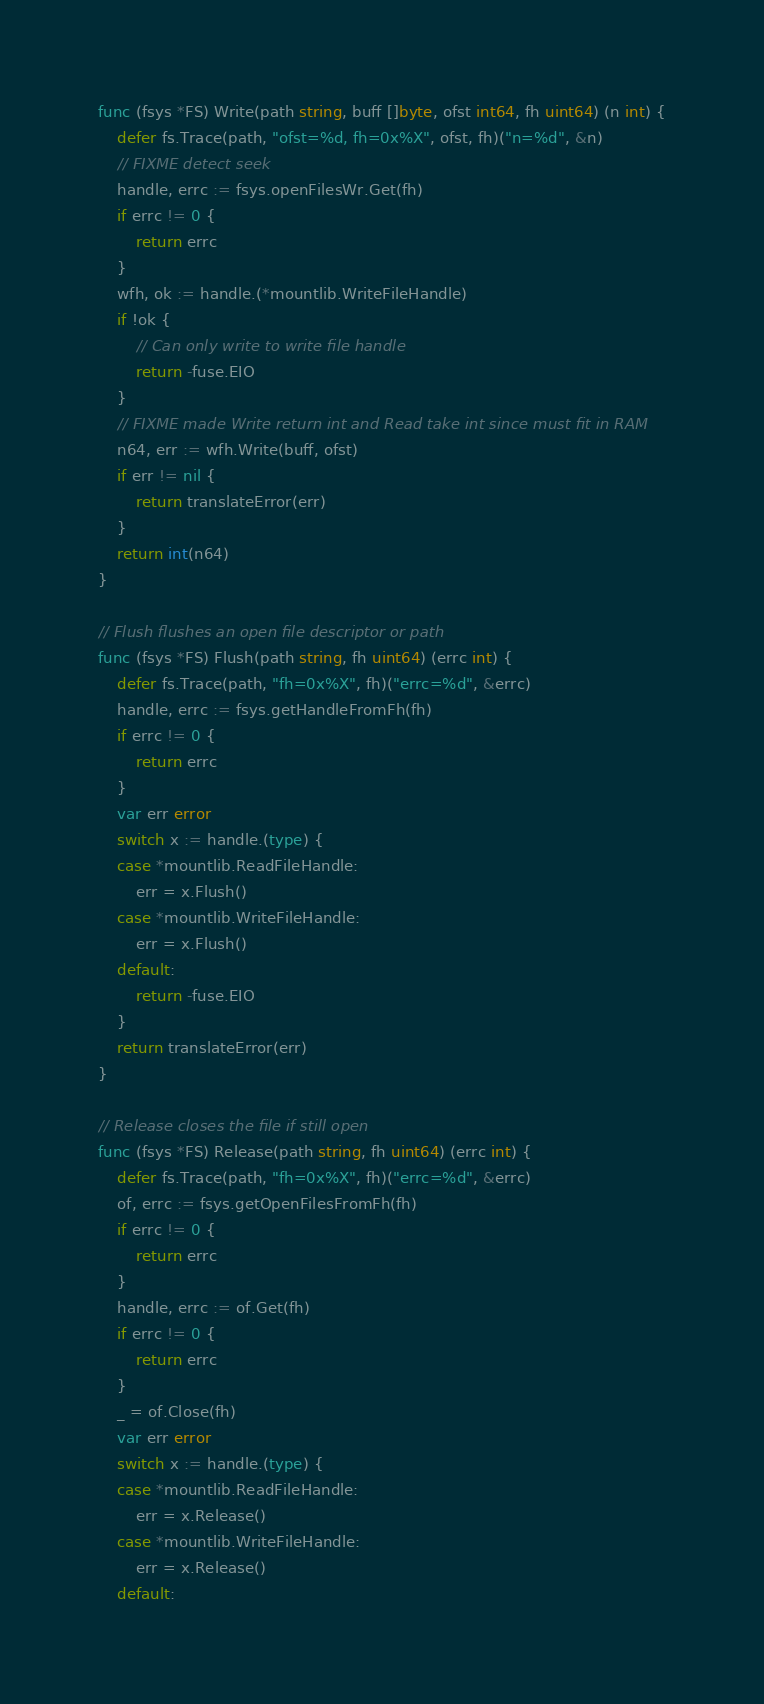Convert code to text. <code><loc_0><loc_0><loc_500><loc_500><_Go_>
func (fsys *FS) Write(path string, buff []byte, ofst int64, fh uint64) (n int) {
	defer fs.Trace(path, "ofst=%d, fh=0x%X", ofst, fh)("n=%d", &n)
	// FIXME detect seek
	handle, errc := fsys.openFilesWr.Get(fh)
	if errc != 0 {
		return errc
	}
	wfh, ok := handle.(*mountlib.WriteFileHandle)
	if !ok {
		// Can only write to write file handle
		return -fuse.EIO
	}
	// FIXME made Write return int and Read take int since must fit in RAM
	n64, err := wfh.Write(buff, ofst)
	if err != nil {
		return translateError(err)
	}
	return int(n64)
}

// Flush flushes an open file descriptor or path
func (fsys *FS) Flush(path string, fh uint64) (errc int) {
	defer fs.Trace(path, "fh=0x%X", fh)("errc=%d", &errc)
	handle, errc := fsys.getHandleFromFh(fh)
	if errc != 0 {
		return errc
	}
	var err error
	switch x := handle.(type) {
	case *mountlib.ReadFileHandle:
		err = x.Flush()
	case *mountlib.WriteFileHandle:
		err = x.Flush()
	default:
		return -fuse.EIO
	}
	return translateError(err)
}

// Release closes the file if still open
func (fsys *FS) Release(path string, fh uint64) (errc int) {
	defer fs.Trace(path, "fh=0x%X", fh)("errc=%d", &errc)
	of, errc := fsys.getOpenFilesFromFh(fh)
	if errc != 0 {
		return errc
	}
	handle, errc := of.Get(fh)
	if errc != 0 {
		return errc
	}
	_ = of.Close(fh)
	var err error
	switch x := handle.(type) {
	case *mountlib.ReadFileHandle:
		err = x.Release()
	case *mountlib.WriteFileHandle:
		err = x.Release()
	default:</code> 